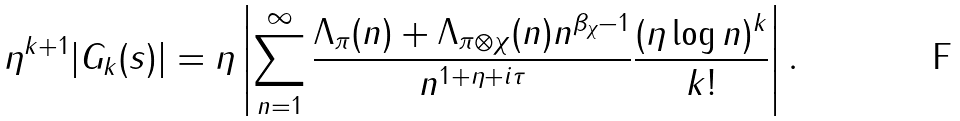<formula> <loc_0><loc_0><loc_500><loc_500>\eta ^ { k + 1 } | G _ { k } ( s ) | = \eta \left | \sum _ { n = 1 } ^ { \infty } \frac { \Lambda _ { \pi } ( n ) + \Lambda _ { \pi \otimes \chi } ( n ) n ^ { \beta _ { \chi } - 1 } } { n ^ { 1 + \eta + i \tau } } \frac { ( \eta \log n ) ^ { k } } { k ! } \right | .</formula> 